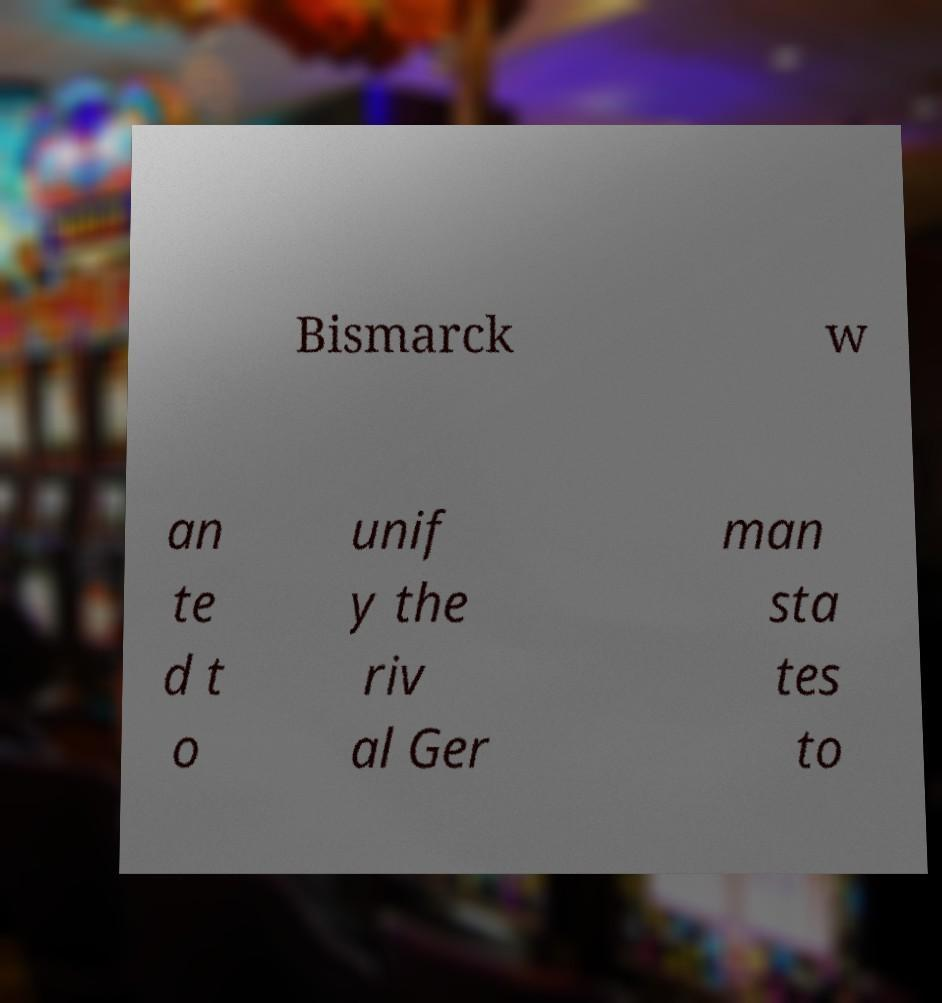Could you assist in decoding the text presented in this image and type it out clearly? Bismarck w an te d t o unif y the riv al Ger man sta tes to 